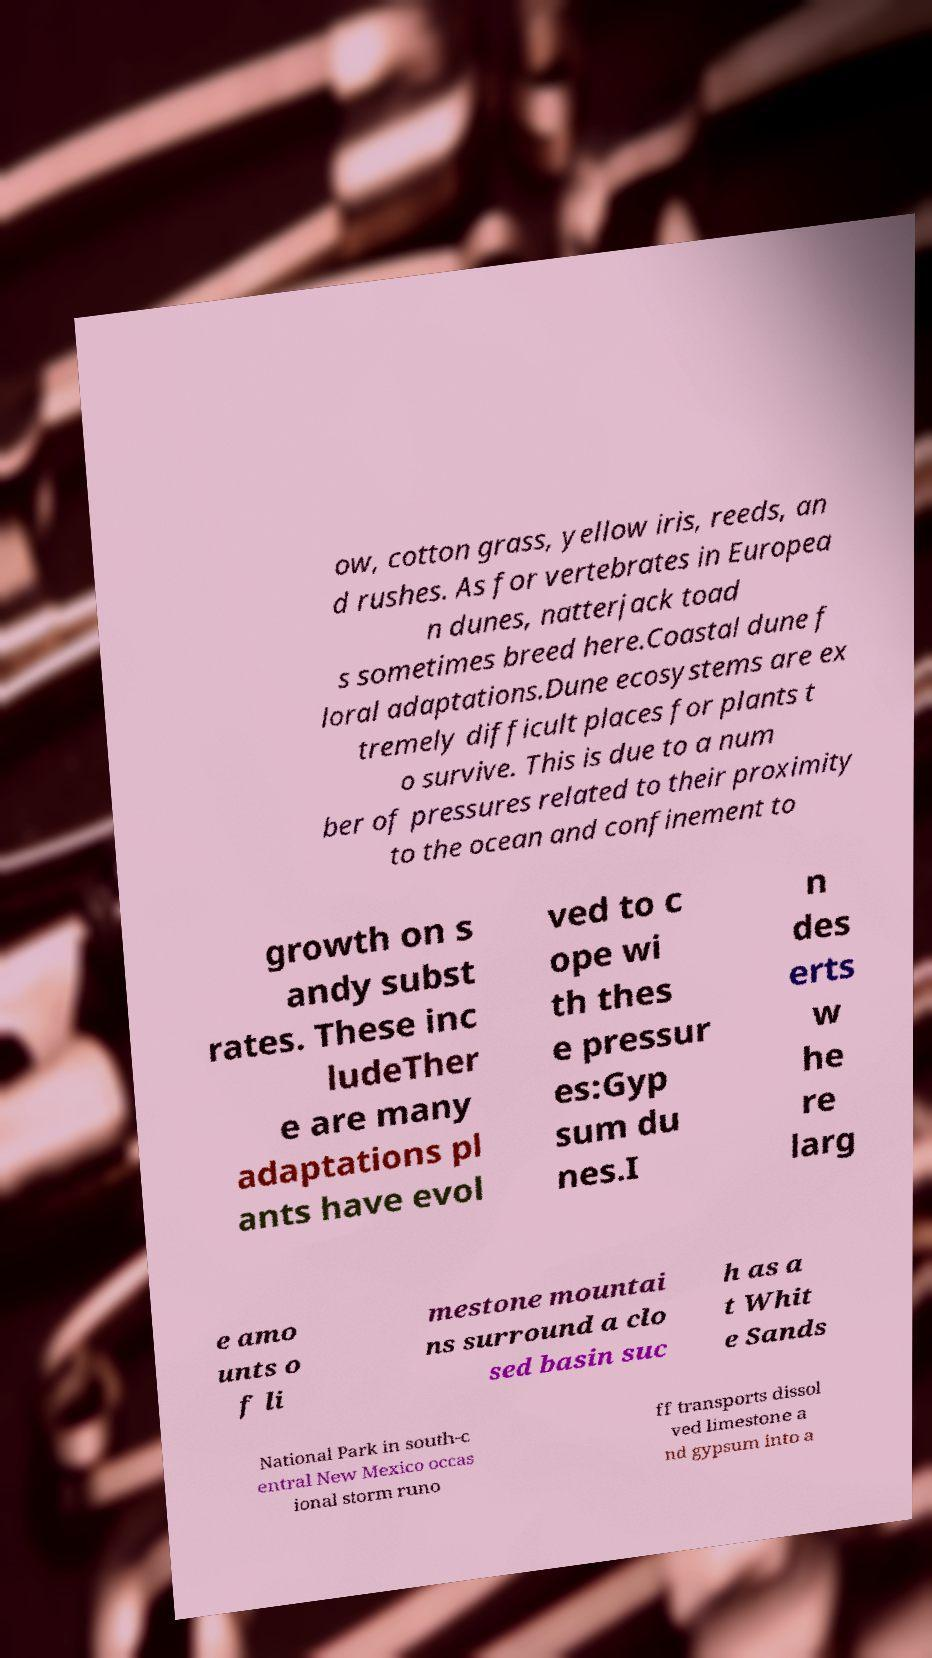What messages or text are displayed in this image? I need them in a readable, typed format. ow, cotton grass, yellow iris, reeds, an d rushes. As for vertebrates in Europea n dunes, natterjack toad s sometimes breed here.Coastal dune f loral adaptations.Dune ecosystems are ex tremely difficult places for plants t o survive. This is due to a num ber of pressures related to their proximity to the ocean and confinement to growth on s andy subst rates. These inc ludeTher e are many adaptations pl ants have evol ved to c ope wi th thes e pressur es:Gyp sum du nes.I n des erts w he re larg e amo unts o f li mestone mountai ns surround a clo sed basin suc h as a t Whit e Sands National Park in south-c entral New Mexico occas ional storm runo ff transports dissol ved limestone a nd gypsum into a 